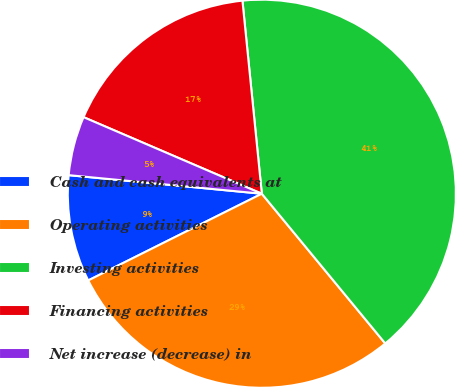<chart> <loc_0><loc_0><loc_500><loc_500><pie_chart><fcel>Cash and cash equivalents at<fcel>Operating activities<fcel>Investing activities<fcel>Financing activities<fcel>Net increase (decrease) in<nl><fcel>8.9%<fcel>28.6%<fcel>40.62%<fcel>16.95%<fcel>4.93%<nl></chart> 